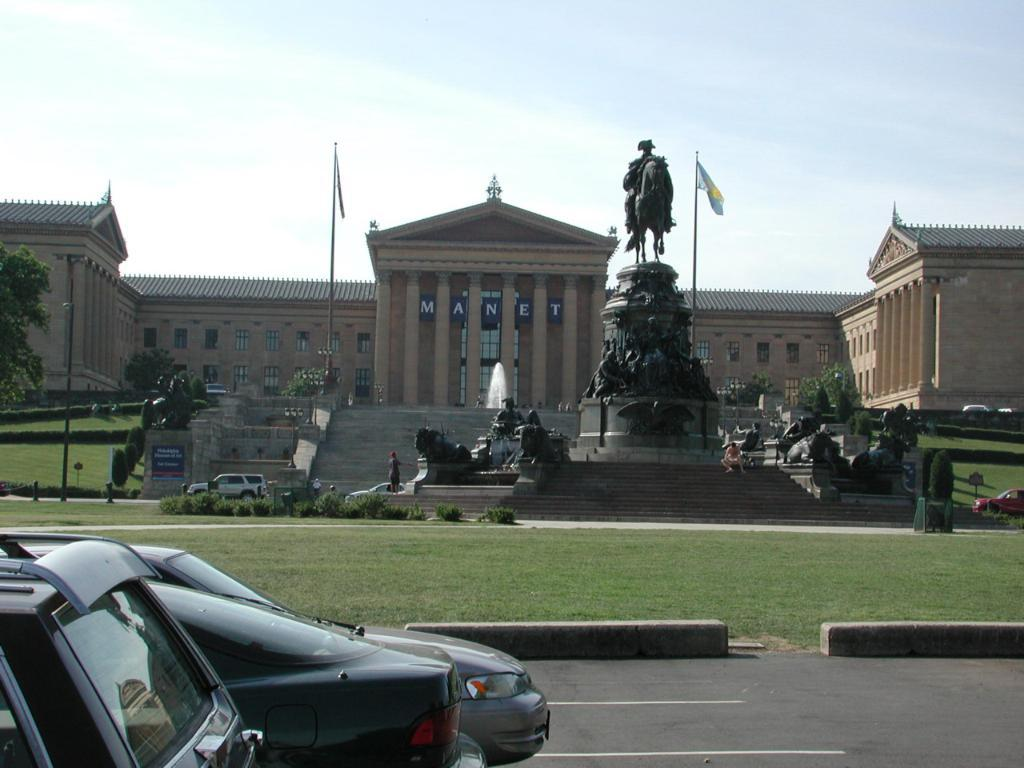What type of vehicles can be seen on the road in the image? There are cars on the road in the image. What type of vegetation is present in the image? There is grass, plants, and trees in the image. What structures can be seen in the image? There are poles, boards, flags, sculptures, and a building in the image. What part of the natural environment is visible in the image? The sky is visible in the background of the image. What account number is associated with the car in the image? There is no account number associated with the car in the image, as it is a photograph and not a financial transaction. What type of basin can be seen in the image? There is no basin present in the image. 